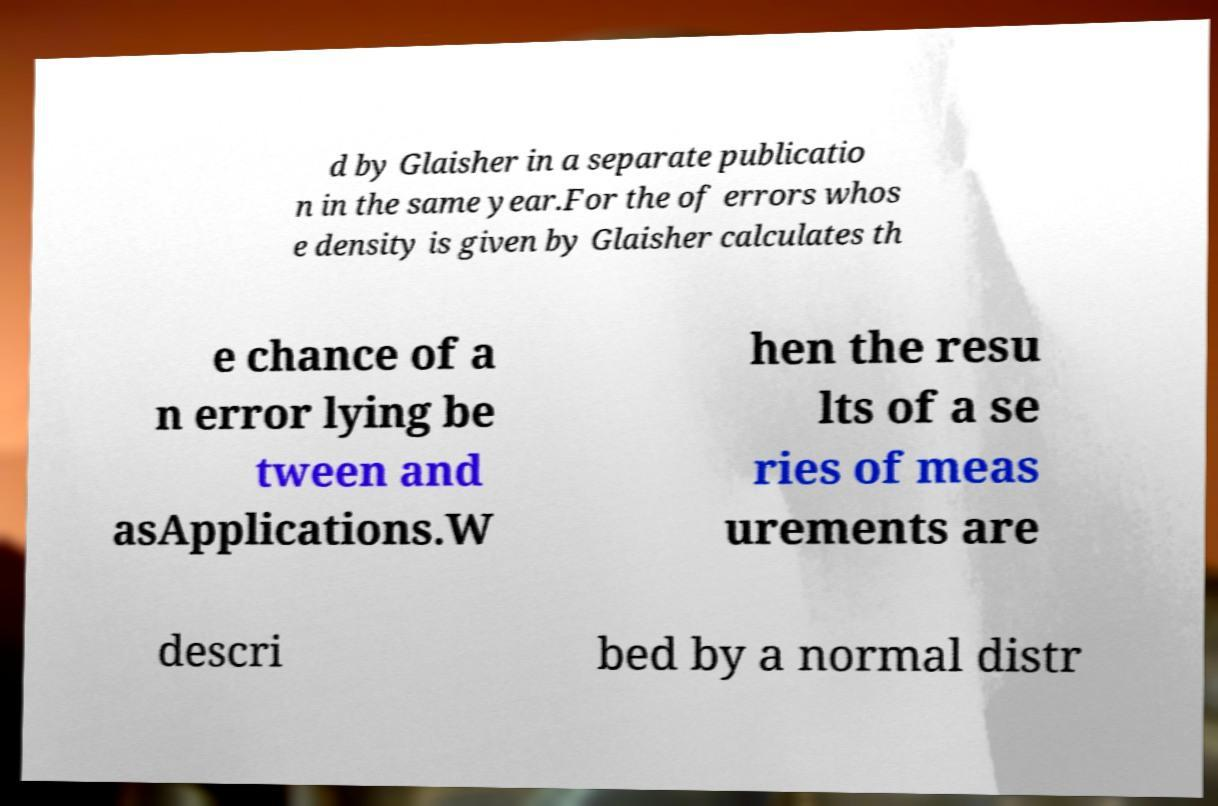I need the written content from this picture converted into text. Can you do that? d by Glaisher in a separate publicatio n in the same year.For the of errors whos e density is given by Glaisher calculates th e chance of a n error lying be tween and asApplications.W hen the resu lts of a se ries of meas urements are descri bed by a normal distr 